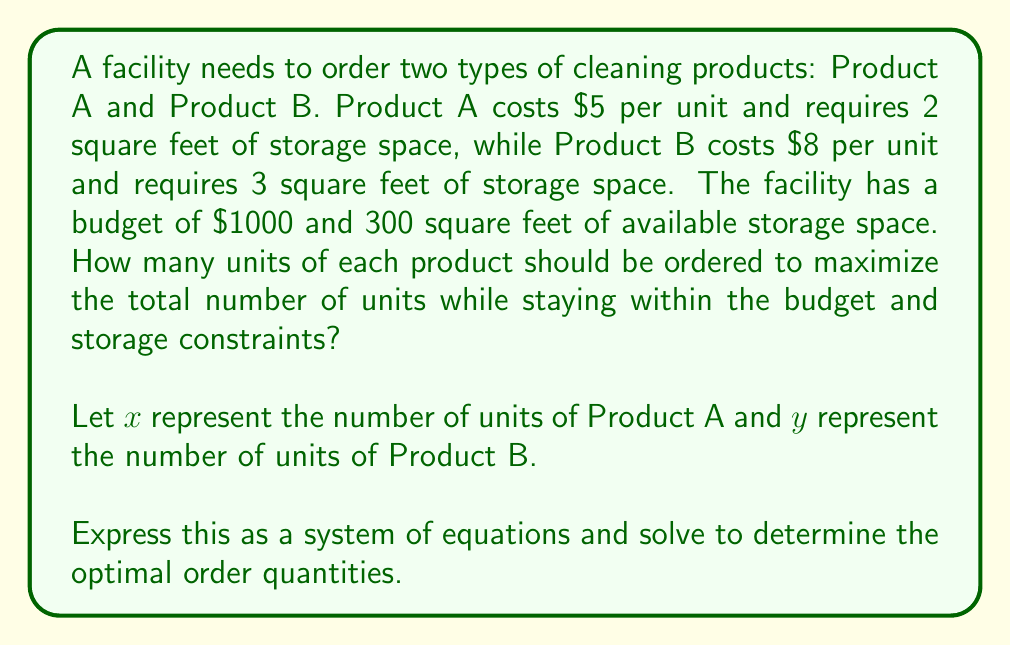Can you solve this math problem? To solve this problem, we need to set up a system of equations based on the given constraints and then maximize the total number of units. Let's approach this step-by-step:

1. Set up the constraints:

   Budget constraint: $5x + 8y \leq 1000$
   Storage constraint: $2x + 3y \leq 300$

2. Our objective is to maximize $x + y$, which represents the total number of units.

3. We can visualize this as a linear programming problem with the following inequalities:

   $$
   \begin{cases}
   5x + 8y \leq 1000 \\
   2x + 3y \leq 300 \\
   x \geq 0 \\
   y \geq 0
   \end{cases}
   $$

4. The optimal solution will be at the intersection of the two constraint lines. To find this point, we solve the system of equations:

   $$
   \begin{cases}
   5x + 8y = 1000 \\
   2x + 3y = 300
   \end{cases}
   $$

5. Multiply the second equation by 5/2 to eliminate x:

   $$
   \begin{cases}
   5x + 8y = 1000 \\
   5x + 7.5y = 750
   \end{cases}
   $$

6. Subtract the second equation from the first:

   $0.5y = 250$

7. Solve for y:

   $y = 500$

8. Substitute this value of y into the second original equation:

   $2x + 3(500) = 300$
   $2x = 300 - 1500 = -1200$
   $x = -600$

9. Since x cannot be negative, we need to find the intersection of one of the constraint lines with the y-axis. Let's use the budget constraint:

   $8y = 1000$
   $y = 125$

10. Now we have two potential solutions: (0, 125) and (0, 100). We choose (0, 125) as it maximizes the total number of units while staying within both constraints.

Therefore, the optimal order is 0 units of Product A and 125 units of Product B.
Answer: Product A: 0 units, Product B: 125 units 